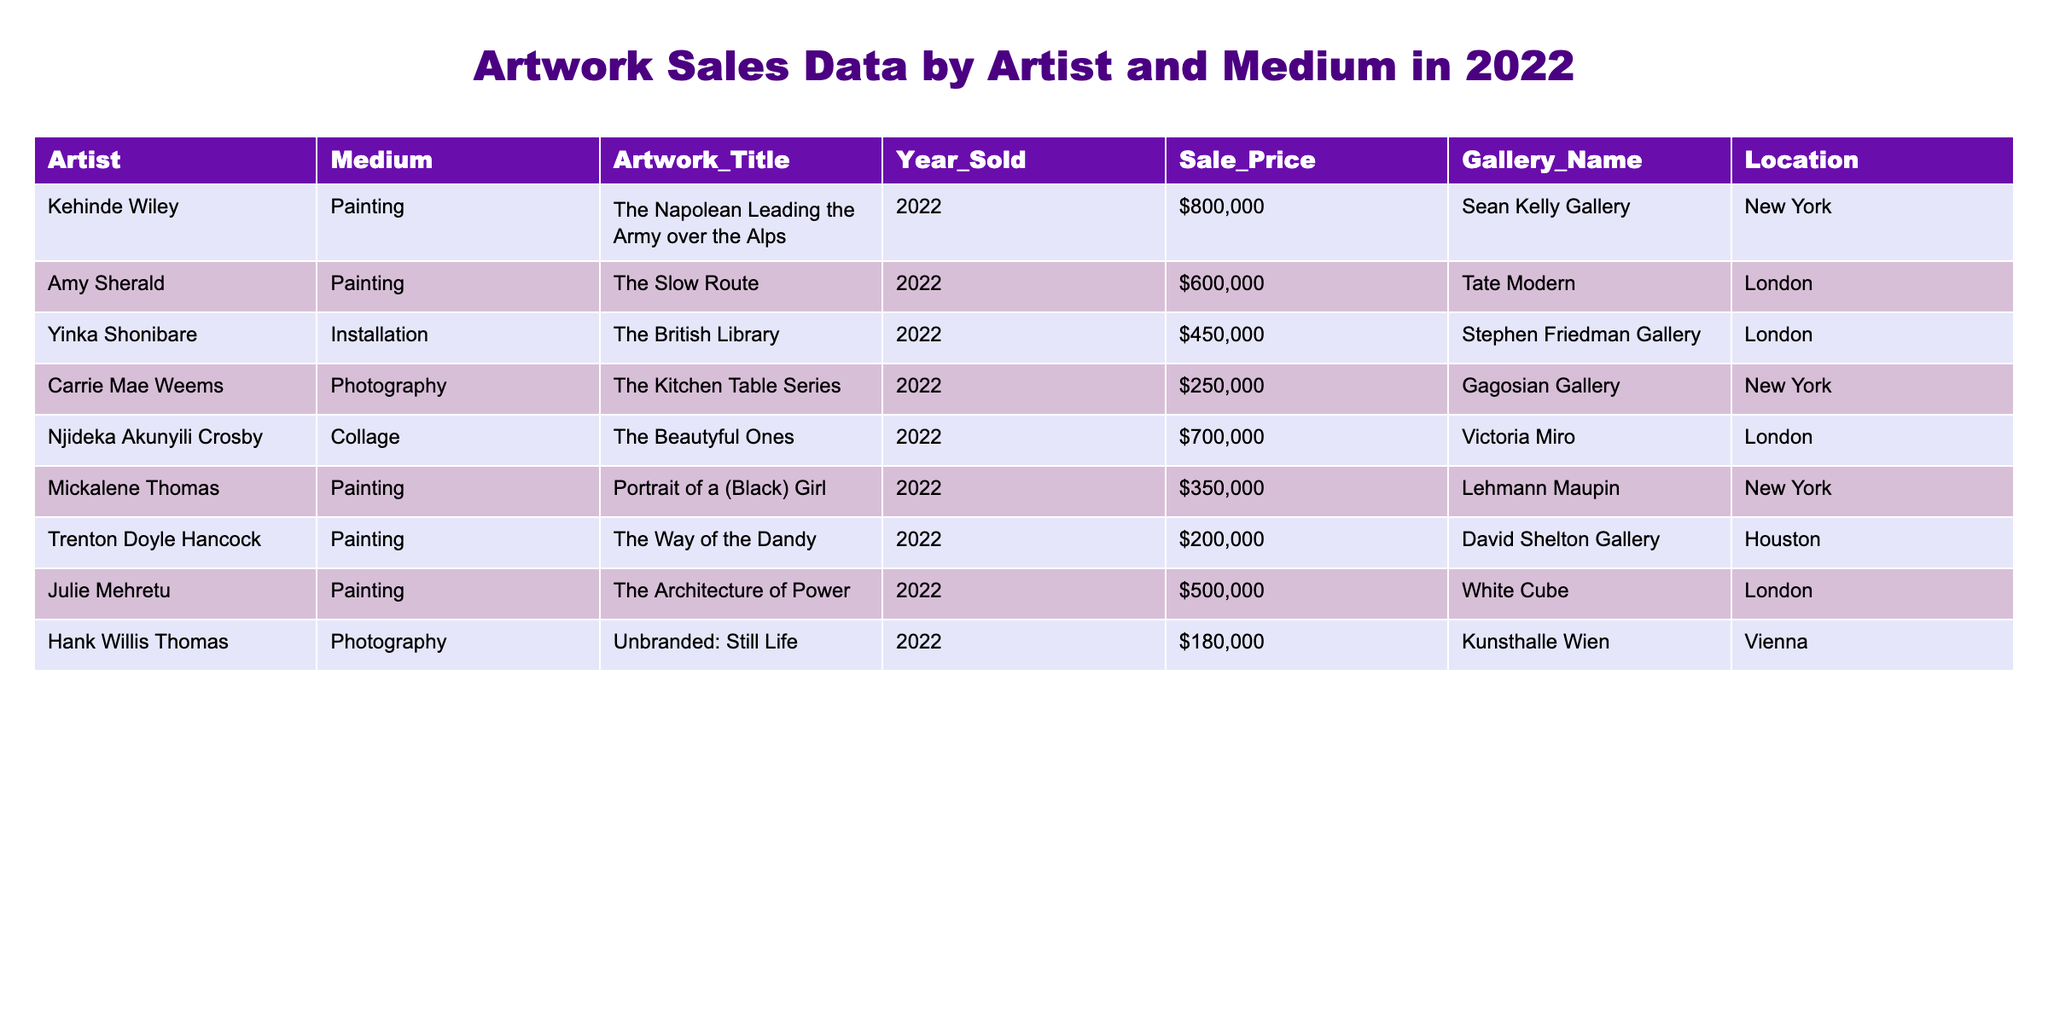What is the highest sale price for an artwork in the table? The highest sale price can be identified by scanning the Sale_Price column. The highest value listed is $800,000, attributed to Kehinde Wiley's painting "The Napolean Leading the Army over the Alps."
Answer: $800,000 Which artist sold the artwork titled "The Kitchen Table Series"? By looking at the Artwork_Title column and finding the corresponding artist, "The Kitchen Table Series" was sold by Carrie Mae Weems.
Answer: Carrie Mae Weems How many artworks were sold in New York? To find the number of artworks sold in New York, we count the entries in the Location column that specifically mention New York. There are three entries that fit this criteria.
Answer: 3 What is the total sale value of all paintings listed? We first identify all entries categorized as "Painting" in the Medium column, which are five artworks. Their sale prices are added together: 800,000 + 600,000 + 350,000 + 200,000 + 500,000 = 2,450,000.
Answer: $2,450,000 Did Yinka Shonibare sell more artworks than Carrie Mae Weems? We check the number of artworks listed for each artist in the table. Yinka Shonibare has one artwork listed, and Carrie Mae Weems also has one artwork. Therefore, neither sold more than the other.
Answer: No What medium was used for the artwork sold at the highest price? The artwork with the highest sale price is Kehinde Wiley's painting, which falls under the "Painting" medium.
Answer: Painting Which artist sold an artwork at a price of $180,000, and what was the title? Scanning the Sale_Price column, the artwork sold for $180,000 was by Hank Willis Thomas, titled "Unbranded: Still Life."
Answer: Hank Willis Thomas, "Unbranded: Still Life" What is the average sale price of artworks sold in London? We examine the entries where the Location is London: Yinka Shonibare ($450,000), Amy Sherald ($600,000), and Julie Mehretu ($500,000). The total sale price is 450,000 + 600,000 + 500,000 = 1,550,000. There are three artworks, so the average is 1,550,000 / 3 = 516,666.67.
Answer: $516,667 How many unique galleries are represented in the table? We assess the Gallery_Name column to identify unique entries. The galleries present are: Sean Kelly Gallery, Tate Modern, Stephen Friedman Gallery, Gagosian Gallery, Victoria Miro, Lehmann Maupin, David Shelton Gallery, and White Cube. This totals eight unique galleries.
Answer: 8 Is there any artwork in the table that was sold for less than $200,000? By scanning through the Sale_Price column, we see that all listed artworks have prices above $180,000, so there are no artworks priced below $200,000.
Answer: No 